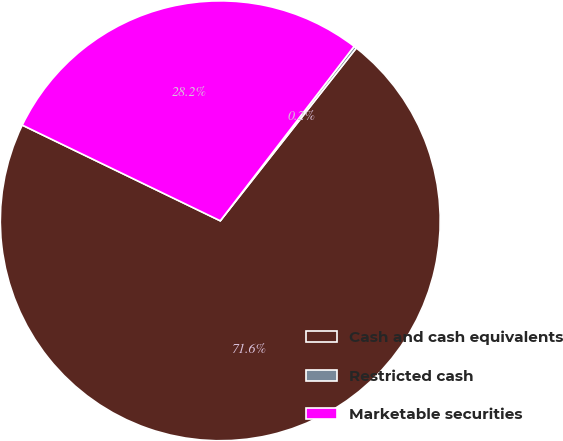<chart> <loc_0><loc_0><loc_500><loc_500><pie_chart><fcel>Cash and cash equivalents<fcel>Restricted cash<fcel>Marketable securities<nl><fcel>71.55%<fcel>0.2%<fcel>28.25%<nl></chart> 